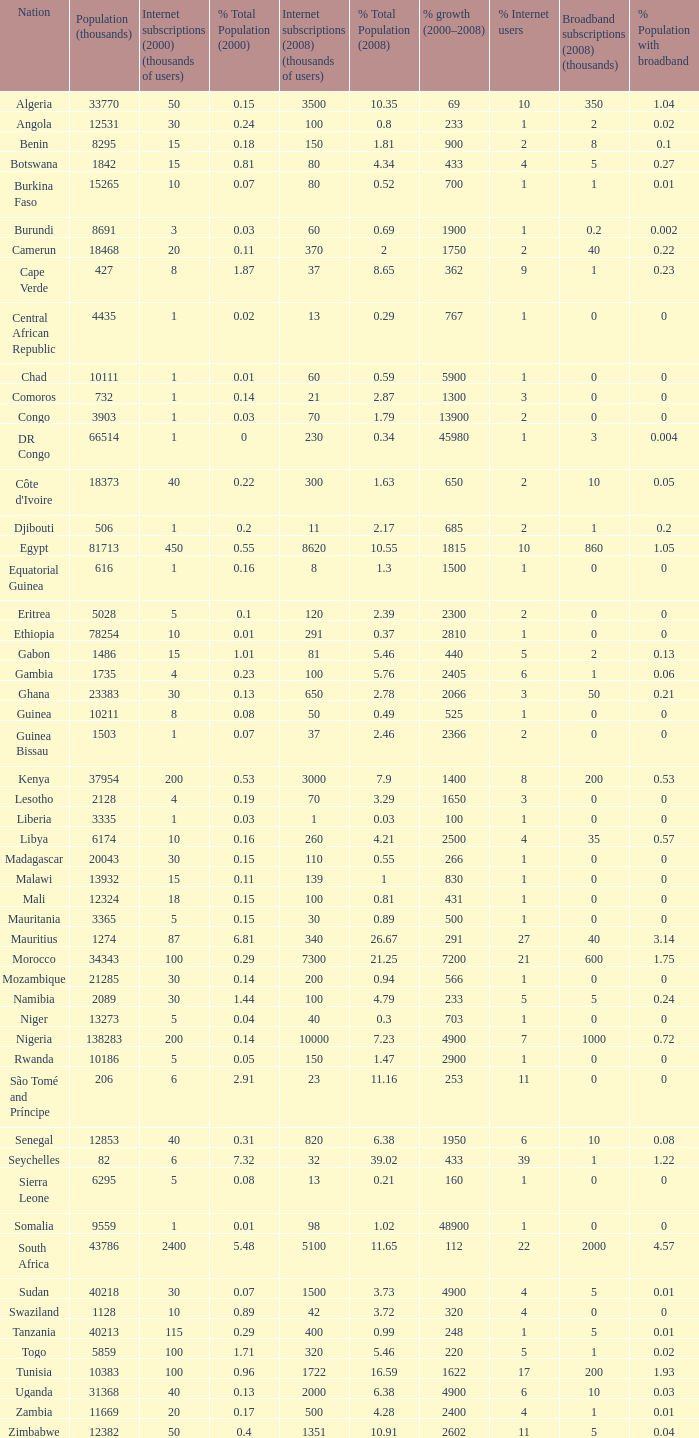Help me parse the entirety of this table. {'header': ['Nation', 'Population (thousands)', 'Internet subscriptions (2000) (thousands of users)', '% Total Population (2000)', 'Internet subscriptions (2008) (thousands of users)', '% Total Population (2008)', '% growth (2000–2008)', '% Internet users', 'Broadband subscriptions (2008) (thousands)', '% Population with broadband'], 'rows': [['Algeria', '33770', '50', '0.15', '3500', '10.35', '69', '10', '350', '1.04'], ['Angola', '12531', '30', '0.24', '100', '0.8', '233', '1', '2', '0.02'], ['Benin', '8295', '15', '0.18', '150', '1.81', '900', '2', '8', '0.1'], ['Botswana', '1842', '15', '0.81', '80', '4.34', '433', '4', '5', '0.27'], ['Burkina Faso', '15265', '10', '0.07', '80', '0.52', '700', '1', '1', '0.01'], ['Burundi', '8691', '3', '0.03', '60', '0.69', '1900', '1', '0.2', '0.002'], ['Camerun', '18468', '20', '0.11', '370', '2', '1750', '2', '40', '0.22'], ['Cape Verde', '427', '8', '1.87', '37', '8.65', '362', '9', '1', '0.23'], ['Central African Republic', '4435', '1', '0.02', '13', '0.29', '767', '1', '0', '0'], ['Chad', '10111', '1', '0.01', '60', '0.59', '5900', '1', '0', '0'], ['Comoros', '732', '1', '0.14', '21', '2.87', '1300', '3', '0', '0'], ['Congo', '3903', '1', '0.03', '70', '1.79', '13900', '2', '0', '0'], ['DR Congo', '66514', '1', '0', '230', '0.34', '45980', '1', '3', '0.004'], ["Côte d'Ivoire", '18373', '40', '0.22', '300', '1.63', '650', '2', '10', '0.05'], ['Djibouti', '506', '1', '0.2', '11', '2.17', '685', '2', '1', '0.2'], ['Egypt', '81713', '450', '0.55', '8620', '10.55', '1815', '10', '860', '1.05'], ['Equatorial Guinea', '616', '1', '0.16', '8', '1.3', '1500', '1', '0', '0'], ['Eritrea', '5028', '5', '0.1', '120', '2.39', '2300', '2', '0', '0'], ['Ethiopia', '78254', '10', '0.01', '291', '0.37', '2810', '1', '0', '0'], ['Gabon', '1486', '15', '1.01', '81', '5.46', '440', '5', '2', '0.13'], ['Gambia', '1735', '4', '0.23', '100', '5.76', '2405', '6', '1', '0.06'], ['Ghana', '23383', '30', '0.13', '650', '2.78', '2066', '3', '50', '0.21'], ['Guinea', '10211', '8', '0.08', '50', '0.49', '525', '1', '0', '0'], ['Guinea Bissau', '1503', '1', '0.07', '37', '2.46', '2366', '2', '0', '0'], ['Kenya', '37954', '200', '0.53', '3000', '7.9', '1400', '8', '200', '0.53'], ['Lesotho', '2128', '4', '0.19', '70', '3.29', '1650', '3', '0', '0'], ['Liberia', '3335', '1', '0.03', '1', '0.03', '100', '1', '0', '0'], ['Libya', '6174', '10', '0.16', '260', '4.21', '2500', '4', '35', '0.57'], ['Madagascar', '20043', '30', '0.15', '110', '0.55', '266', '1', '0', '0'], ['Malawi', '13932', '15', '0.11', '139', '1', '830', '1', '0', '0'], ['Mali', '12324', '18', '0.15', '100', '0.81', '431', '1', '0', '0'], ['Mauritania', '3365', '5', '0.15', '30', '0.89', '500', '1', '0', '0'], ['Mauritius', '1274', '87', '6.81', '340', '26.67', '291', '27', '40', '3.14'], ['Morocco', '34343', '100', '0.29', '7300', '21.25', '7200', '21', '600', '1.75'], ['Mozambique', '21285', '30', '0.14', '200', '0.94', '566', '1', '0', '0'], ['Namibia', '2089', '30', '1.44', '100', '4.79', '233', '5', '5', '0.24'], ['Niger', '13273', '5', '0.04', '40', '0.3', '703', '1', '0', '0'], ['Nigeria', '138283', '200', '0.14', '10000', '7.23', '4900', '7', '1000', '0.72'], ['Rwanda', '10186', '5', '0.05', '150', '1.47', '2900', '1', '0', '0'], ['São Tomé and Príncipe', '206', '6', '2.91', '23', '11.16', '253', '11', '0', '0'], ['Senegal', '12853', '40', '0.31', '820', '6.38', '1950', '6', '10', '0.08'], ['Seychelles', '82', '6', '7.32', '32', '39.02', '433', '39', '1', '1.22'], ['Sierra Leone', '6295', '5', '0.08', '13', '0.21', '160', '1', '0', '0'], ['Somalia', '9559', '1', '0.01', '98', '1.02', '48900', '1', '0', '0'], ['South Africa', '43786', '2400', '5.48', '5100', '11.65', '112', '22', '2000', '4.57'], ['Sudan', '40218', '30', '0.07', '1500', '3.73', '4900', '4', '5', '0.01'], ['Swaziland', '1128', '10', '0.89', '42', '3.72', '320', '4', '0', '0'], ['Tanzania', '40213', '115', '0.29', '400', '0.99', '248', '1', '5', '0.01'], ['Togo', '5859', '100', '1.71', '320', '5.46', '220', '5', '1', '0.02'], ['Tunisia', '10383', '100', '0.96', '1722', '16.59', '1622', '17', '200', '1.93'], ['Uganda', '31368', '40', '0.13', '2000', '6.38', '4900', '6', '10', '0.03'], ['Zambia', '11669', '20', '0.17', '500', '4.28', '2400', '4', '1', '0.01'], ['Zimbabwe', '12382', '50', '0.4', '1351', '10.91', '2602', '11', '5', '0.04']]} Name the total number of percentage growth 2000-2008 of uganda? 1.0. 